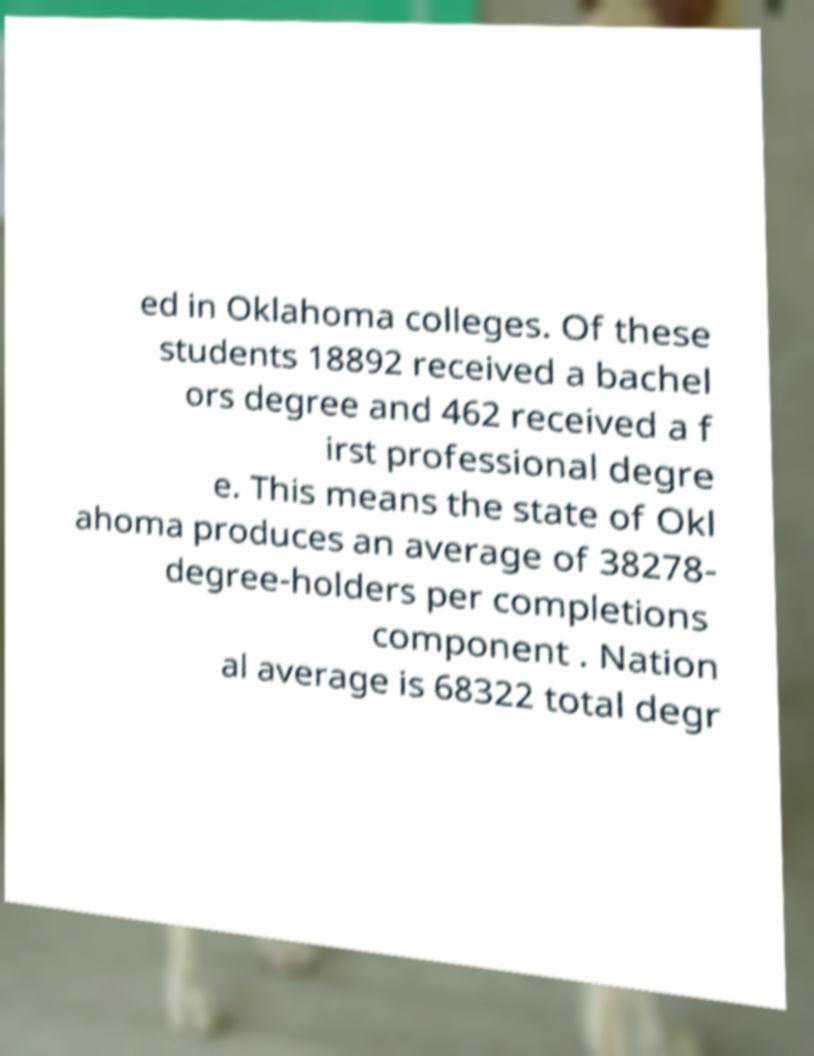Can you accurately transcribe the text from the provided image for me? ed in Oklahoma colleges. Of these students 18892 received a bachel ors degree and 462 received a f irst professional degre e. This means the state of Okl ahoma produces an average of 38278- degree-holders per completions component . Nation al average is 68322 total degr 